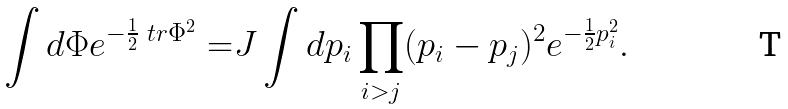Convert formula to latex. <formula><loc_0><loc_0><loc_500><loc_500>\int d \Phi e ^ { - \frac { 1 } 2 \ t r \Phi ^ { 2 } } = & J \int d p _ { i } \prod _ { i > j } ( p _ { i } - p _ { j } ) ^ { 2 } e ^ { - \frac { 1 } 2 p _ { i } ^ { 2 } } .</formula> 